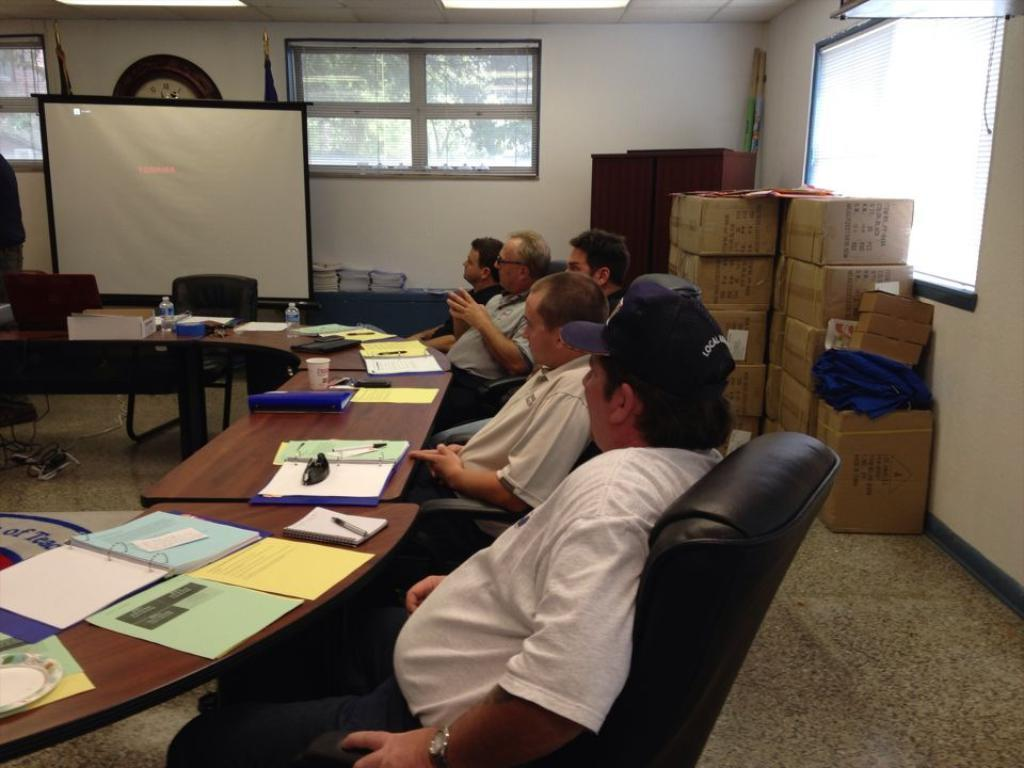What are the people in the image doing? The people in the image are sitting on chairs. In which direction are the people looking? The people are looking to the left. What can be seen in the middle of the image? There is a glass window in the middle of the image. What is behind the people in the image? There is a wall behind the people. What type of wool is being used to insulate the ice in the image? There is no wool or ice present in the image; it features people sitting on chairs and looking to the left, with a glass window and a wall in the background. 